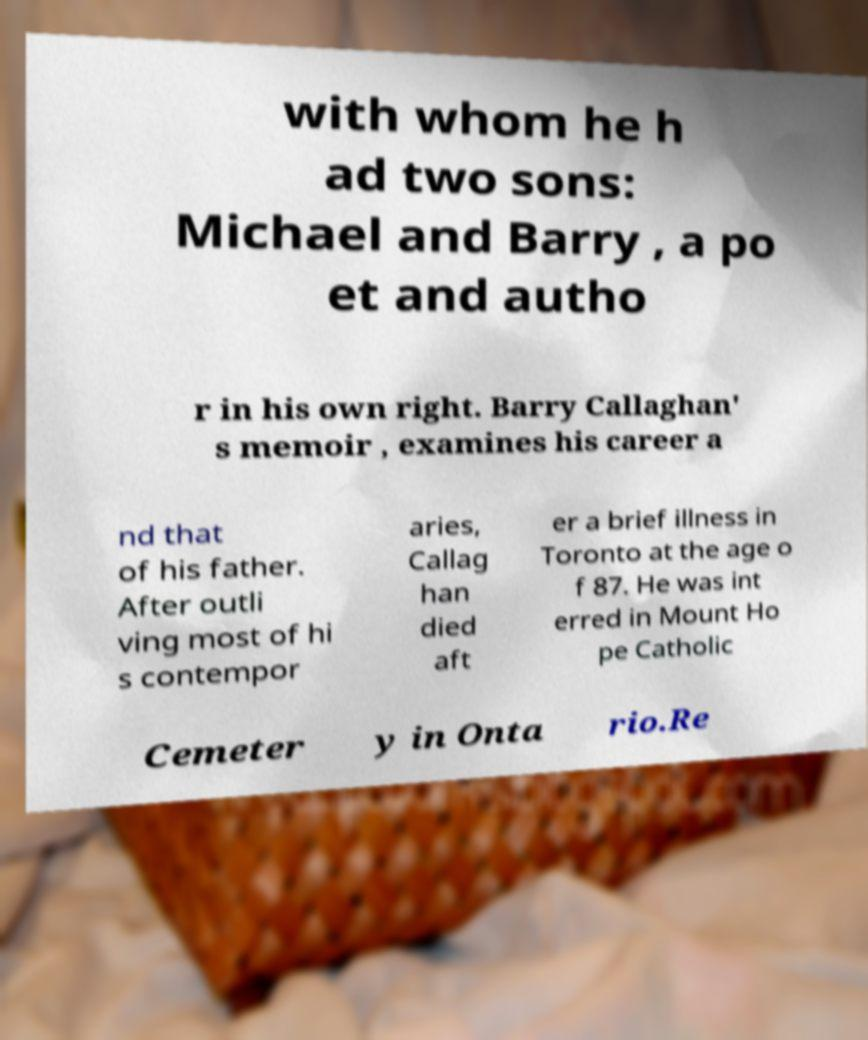What messages or text are displayed in this image? I need them in a readable, typed format. with whom he h ad two sons: Michael and Barry , a po et and autho r in his own right. Barry Callaghan' s memoir , examines his career a nd that of his father. After outli ving most of hi s contempor aries, Callag han died aft er a brief illness in Toronto at the age o f 87. He was int erred in Mount Ho pe Catholic Cemeter y in Onta rio.Re 